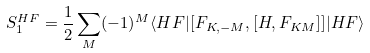Convert formula to latex. <formula><loc_0><loc_0><loc_500><loc_500>S _ { 1 } ^ { H F } = \frac { 1 } { 2 } \sum _ { M } ( - 1 ) ^ { M } \langle H F | [ F _ { K , - M } , [ H , F _ { K M } ] ] | H F \rangle</formula> 